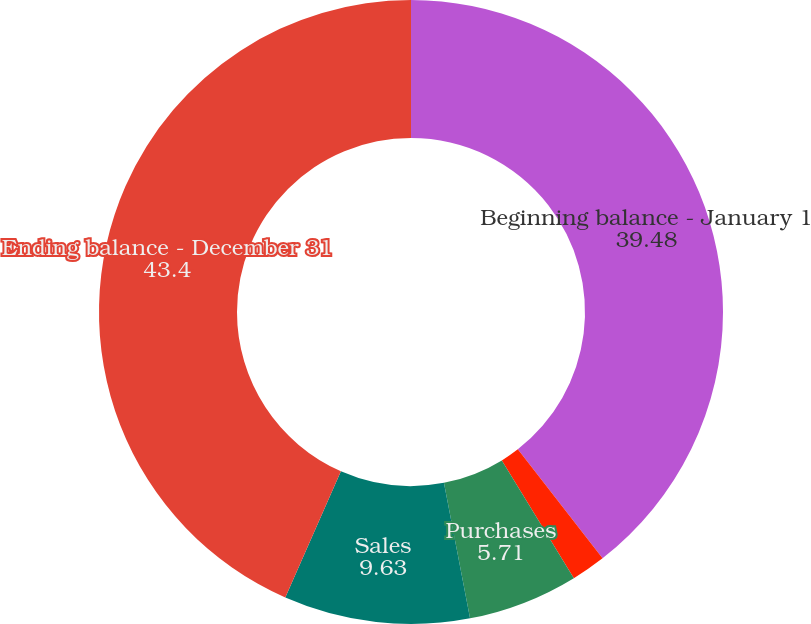Convert chart to OTSL. <chart><loc_0><loc_0><loc_500><loc_500><pie_chart><fcel>Beginning balance - January 1<fcel>Realized gain/(loss)<fcel>Purchases<fcel>Sales<fcel>Ending balance - December 31<nl><fcel>39.48%<fcel>1.78%<fcel>5.71%<fcel>9.63%<fcel>43.4%<nl></chart> 